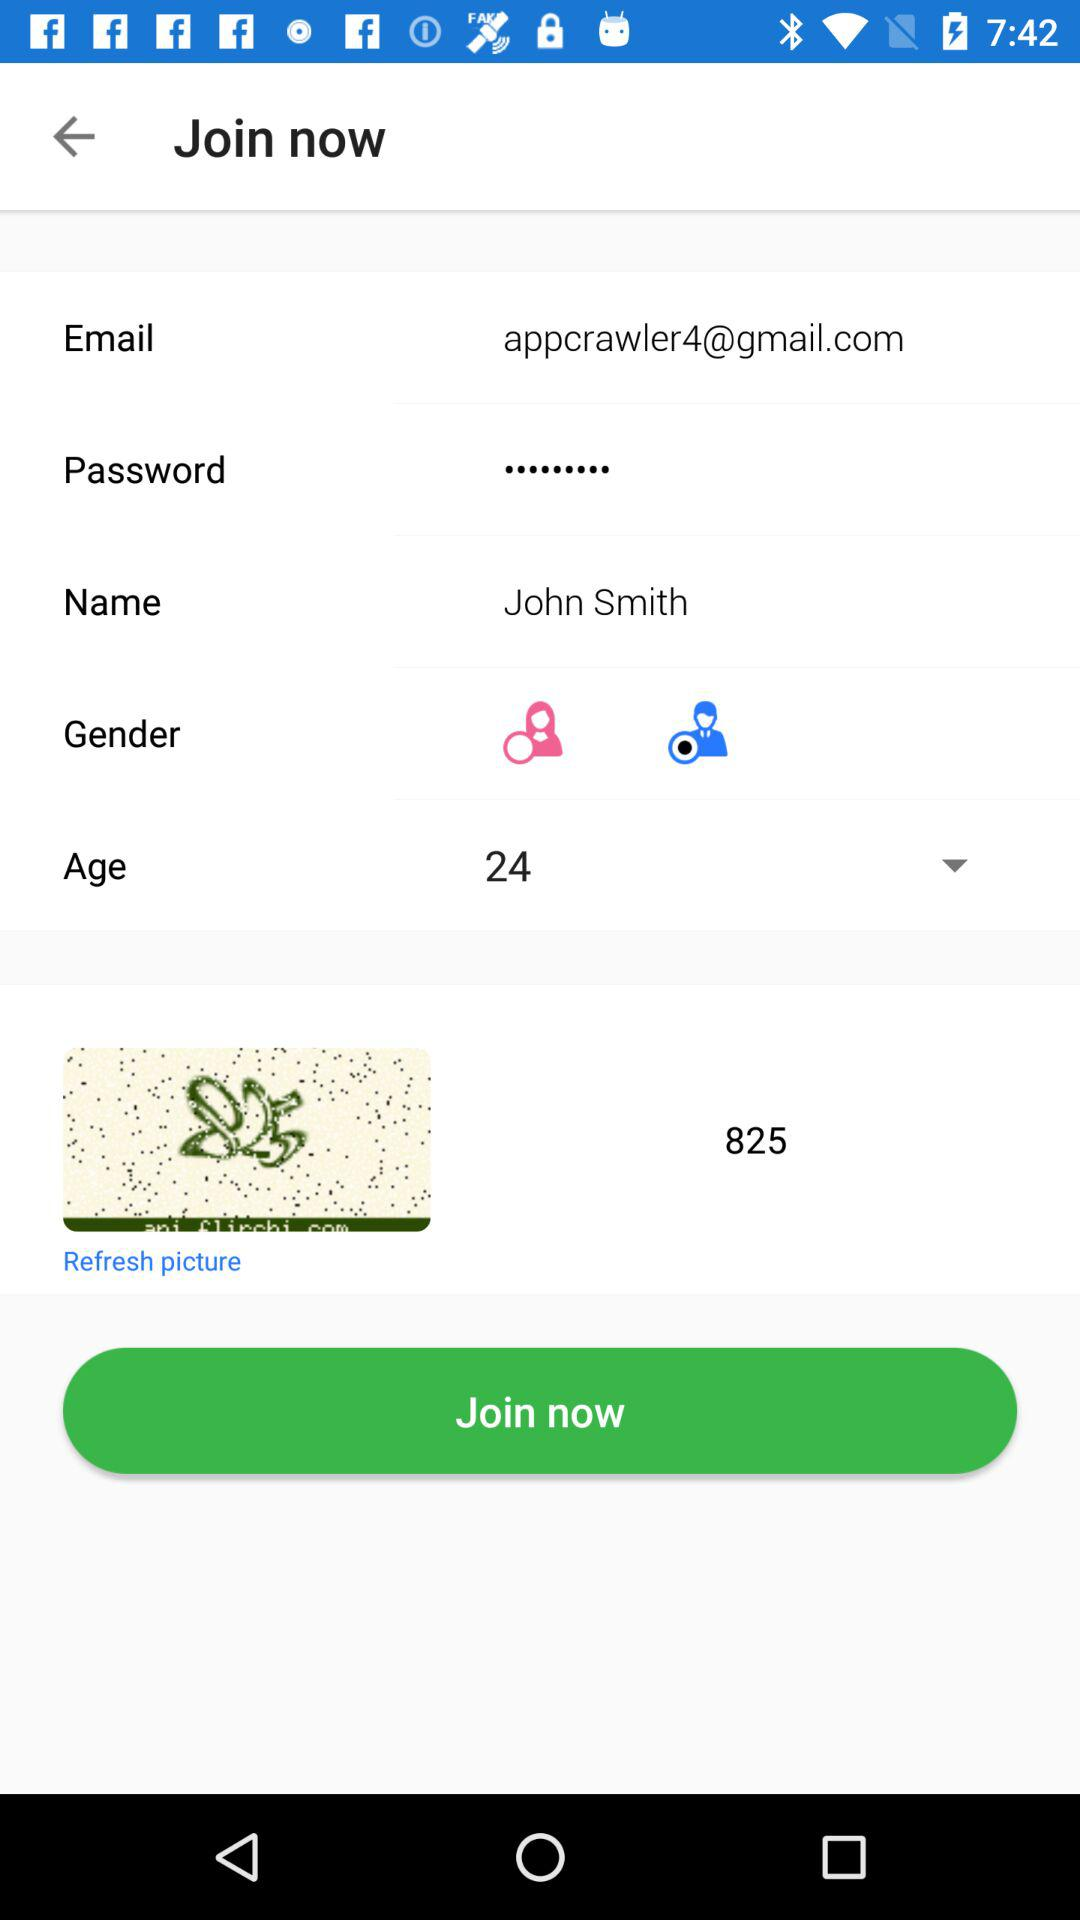What is the age? The age is 24 years. 